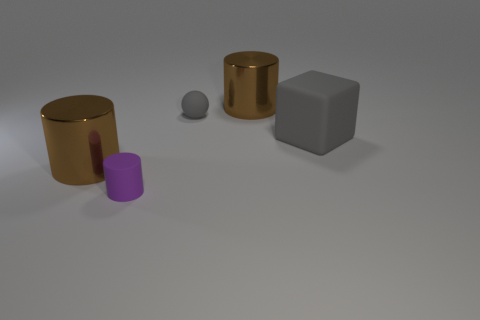Is the number of rubber blocks that are to the left of the tiny gray matte thing less than the number of tiny blue matte cylinders?
Offer a very short reply. No. There is a block that is made of the same material as the gray sphere; what size is it?
Provide a succinct answer. Large. Is the number of brown metal cylinders less than the number of big brown metallic cubes?
Ensure brevity in your answer.  No. How many large objects are either gray matte blocks or gray matte things?
Your answer should be very brief. 1. How many big cylinders are both behind the gray block and on the left side of the rubber cylinder?
Offer a terse response. 0. Are there more big blocks than large yellow matte spheres?
Offer a terse response. Yes. How many other things are the same shape as the large gray rubber object?
Provide a short and direct response. 0. Does the cube have the same color as the small sphere?
Offer a very short reply. Yes. There is a big thing that is in front of the small gray rubber object and to the right of the purple rubber cylinder; what material is it?
Your answer should be very brief. Rubber. The gray rubber cube is what size?
Make the answer very short. Large. 